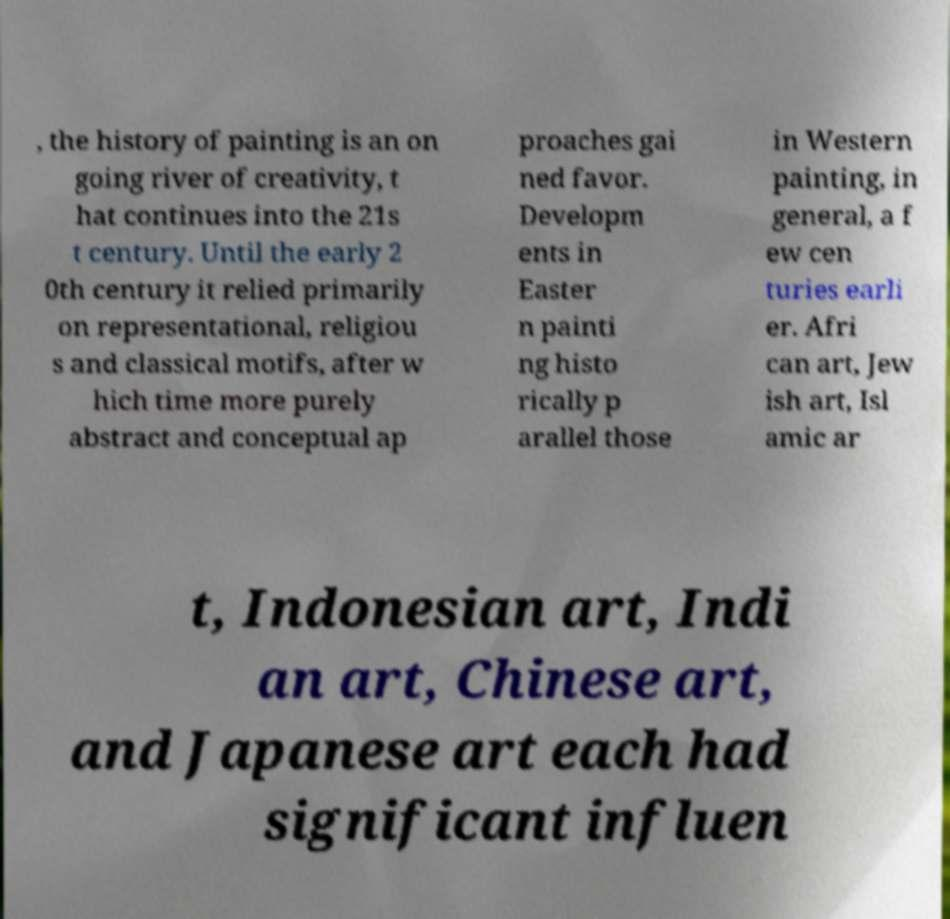What messages or text are displayed in this image? I need them in a readable, typed format. , the history of painting is an on going river of creativity, t hat continues into the 21s t century. Until the early 2 0th century it relied primarily on representational, religiou s and classical motifs, after w hich time more purely abstract and conceptual ap proaches gai ned favor. Developm ents in Easter n painti ng histo rically p arallel those in Western painting, in general, a f ew cen turies earli er. Afri can art, Jew ish art, Isl amic ar t, Indonesian art, Indi an art, Chinese art, and Japanese art each had significant influen 